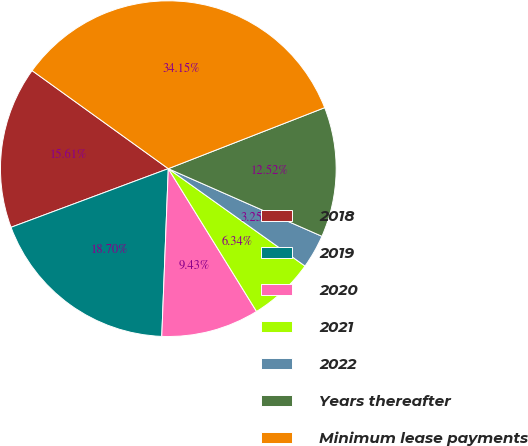<chart> <loc_0><loc_0><loc_500><loc_500><pie_chart><fcel>2018<fcel>2019<fcel>2020<fcel>2021<fcel>2022<fcel>Years thereafter<fcel>Minimum lease payments<nl><fcel>15.61%<fcel>18.7%<fcel>9.43%<fcel>6.34%<fcel>3.25%<fcel>12.52%<fcel>34.15%<nl></chart> 